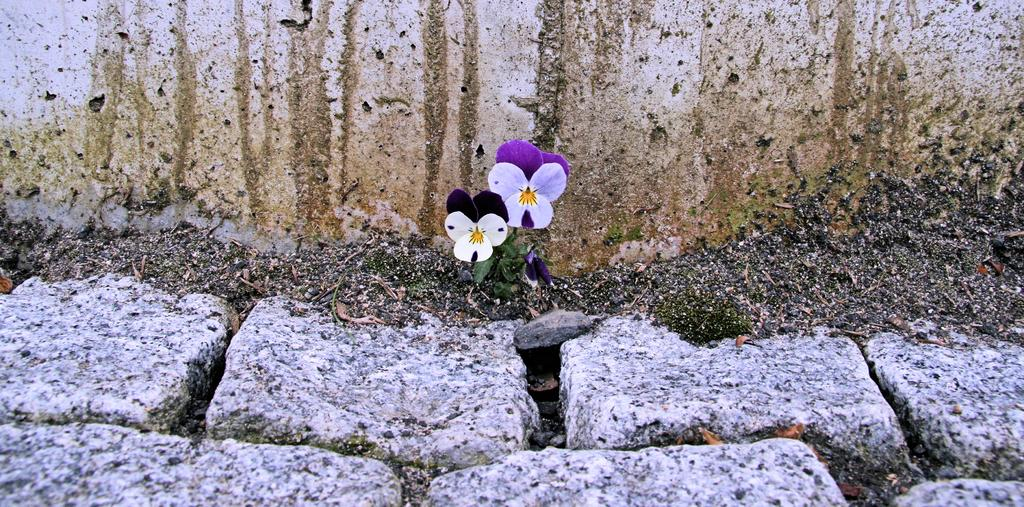What type of vegetation can be seen on the ground in the image? There are flowers on the ground in the image. What colors are the flowers? The flowers are white and violet in color. What other objects can be seen on the ground in the image? There are stones visible in the image. What structure is present in the image? There is a wall in the image. What type of train can be seen passing by the wall in the image? There is no train present in the image; it only features flowers, stones, and a wall. 